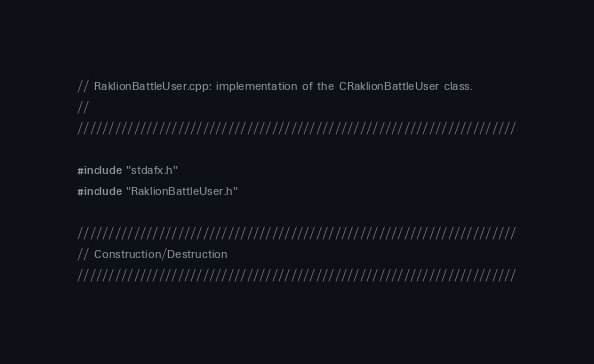<code> <loc_0><loc_0><loc_500><loc_500><_C++_>// RaklionBattleUser.cpp: implementation of the CRaklionBattleUser class.
//
//////////////////////////////////////////////////////////////////////

#include "stdafx.h"
#include "RaklionBattleUser.h"

//////////////////////////////////////////////////////////////////////
// Construction/Destruction
//////////////////////////////////////////////////////////////////////
</code> 